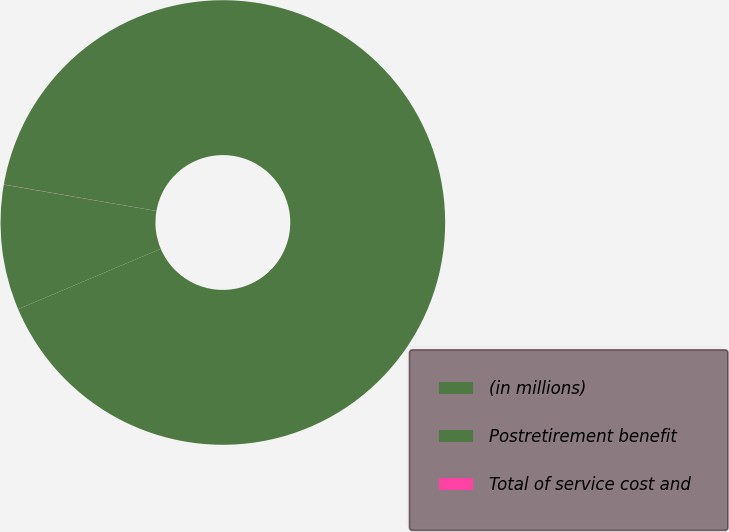Convert chart to OTSL. <chart><loc_0><loc_0><loc_500><loc_500><pie_chart><fcel>(in millions)<fcel>Postretirement benefit<fcel>Total of service cost and<nl><fcel>90.89%<fcel>9.1%<fcel>0.01%<nl></chart> 